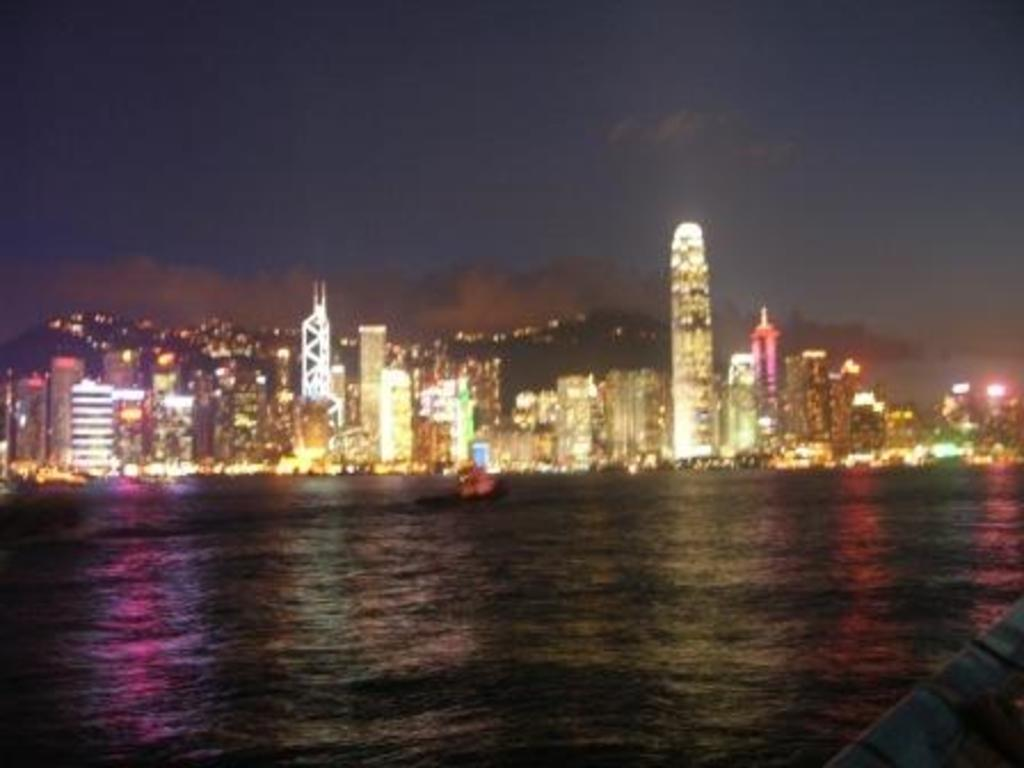What type of location is shown in the image? The image depicts a city. What structures can be seen in the city? There are buildings in the image. What mode of transportation is present on the water? There is a boat on the water in the image. What is visible at the top of the image? The sky is visible at the top of the image, and there are clouds in the sky. What is present at the bottom of the image? Water is present at the bottom of the image. What type of grass can be seen growing on the boat in the image? There is no grass present on the boat in the image. How does the horn on the boat sound in the image? There is no horn present on the boat in the image. 